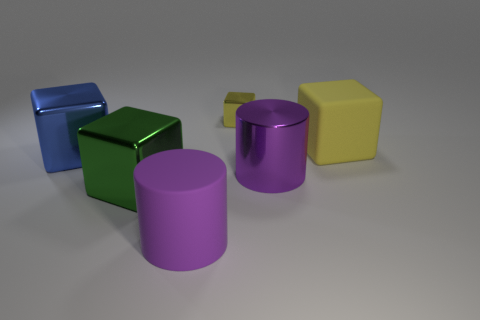There is a purple metallic thing; is its shape the same as the large matte thing in front of the large blue object?
Provide a succinct answer. Yes. What number of other objects are the same size as the matte block?
Keep it short and to the point. 4. What number of gray objects are either shiny cubes or matte things?
Offer a very short reply. 0. How many metal objects are on the right side of the big blue metallic thing and in front of the matte cube?
Your answer should be very brief. 2. There is a large cube to the right of the big matte thing to the left of the metal block behind the large blue block; what is its material?
Your answer should be compact. Rubber. How many small objects have the same material as the small block?
Give a very brief answer. 0. What is the shape of the matte object that is the same color as the metallic cylinder?
Your answer should be compact. Cylinder. The yellow rubber thing that is the same size as the purple rubber thing is what shape?
Provide a succinct answer. Cube. There is another block that is the same color as the rubber cube; what is it made of?
Give a very brief answer. Metal. Are there any big matte things to the right of the purple matte cylinder?
Your answer should be very brief. Yes. 